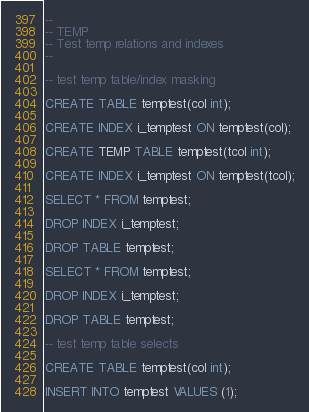Convert code to text. <code><loc_0><loc_0><loc_500><loc_500><_SQL_>--
-- TEMP
-- Test temp relations and indexes
--

-- test temp table/index masking

CREATE TABLE temptest(col int);

CREATE INDEX i_temptest ON temptest(col);

CREATE TEMP TABLE temptest(tcol int);

CREATE INDEX i_temptest ON temptest(tcol);

SELECT * FROM temptest;

DROP INDEX i_temptest;

DROP TABLE temptest;

SELECT * FROM temptest;

DROP INDEX i_temptest;

DROP TABLE temptest;

-- test temp table selects

CREATE TABLE temptest(col int);

INSERT INTO temptest VALUES (1);
</code> 